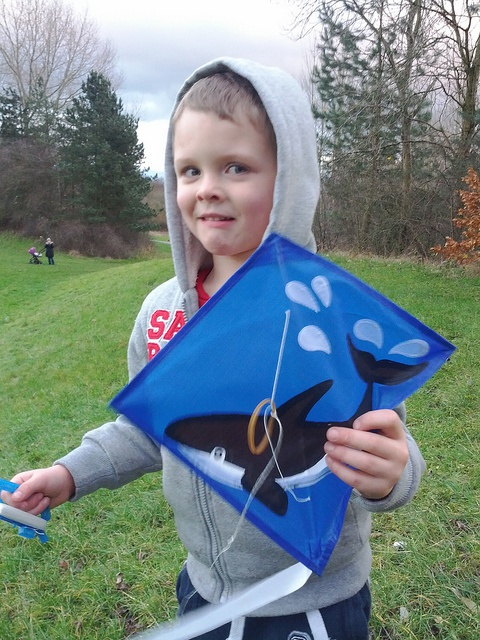Describe the objects in this image and their specific colors. I can see people in white, darkgray, blue, and black tones, kite in white, blue, black, and darkblue tones, and people in white, black, gray, purple, and darkgray tones in this image. 